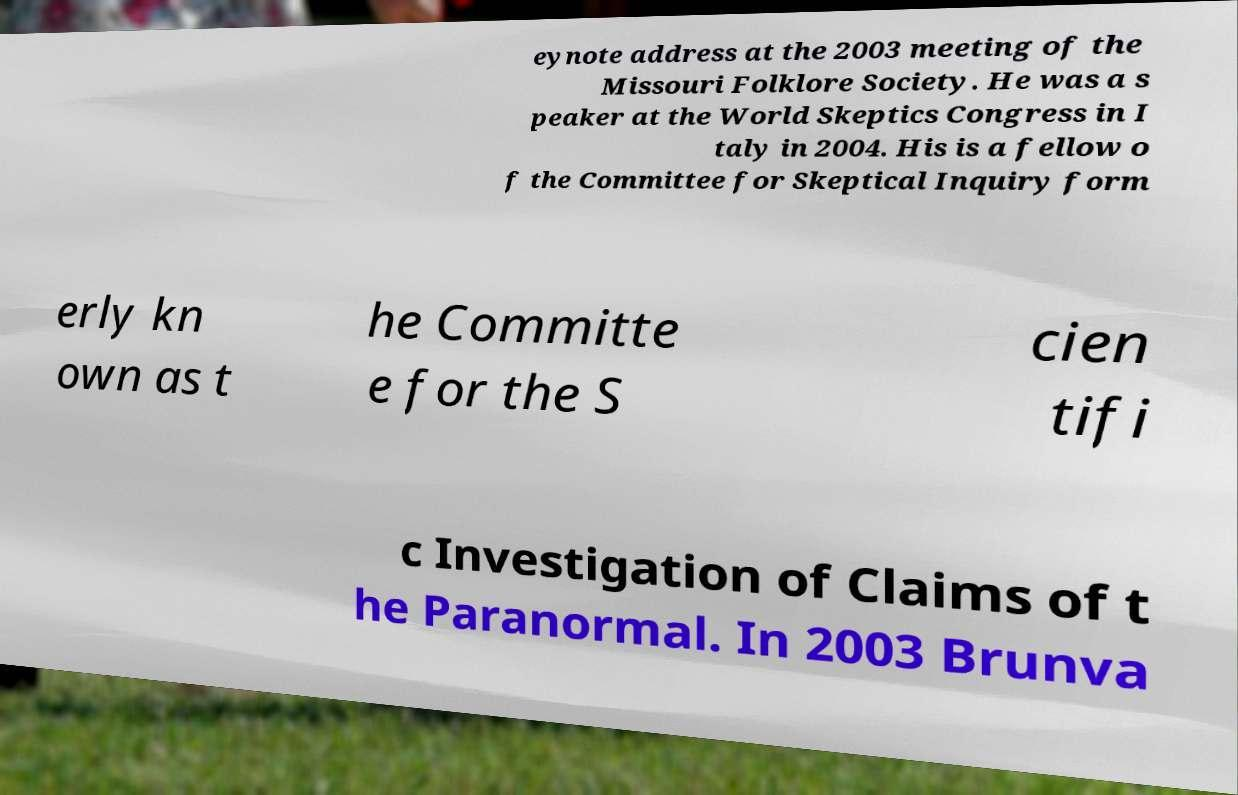There's text embedded in this image that I need extracted. Can you transcribe it verbatim? eynote address at the 2003 meeting of the Missouri Folklore Society. He was a s peaker at the World Skeptics Congress in I taly in 2004. His is a fellow o f the Committee for Skeptical Inquiry form erly kn own as t he Committe e for the S cien tifi c Investigation of Claims of t he Paranormal. In 2003 Brunva 